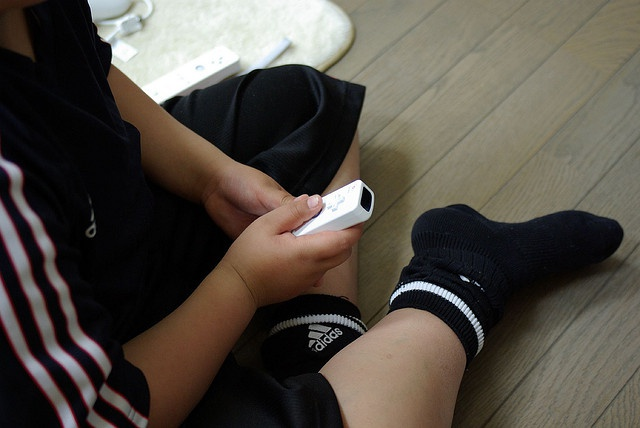Describe the objects in this image and their specific colors. I can see people in black, maroon, and gray tones, remote in black, white, and darkgray tones, and remote in black, white, darkgray, gray, and lightgray tones in this image. 